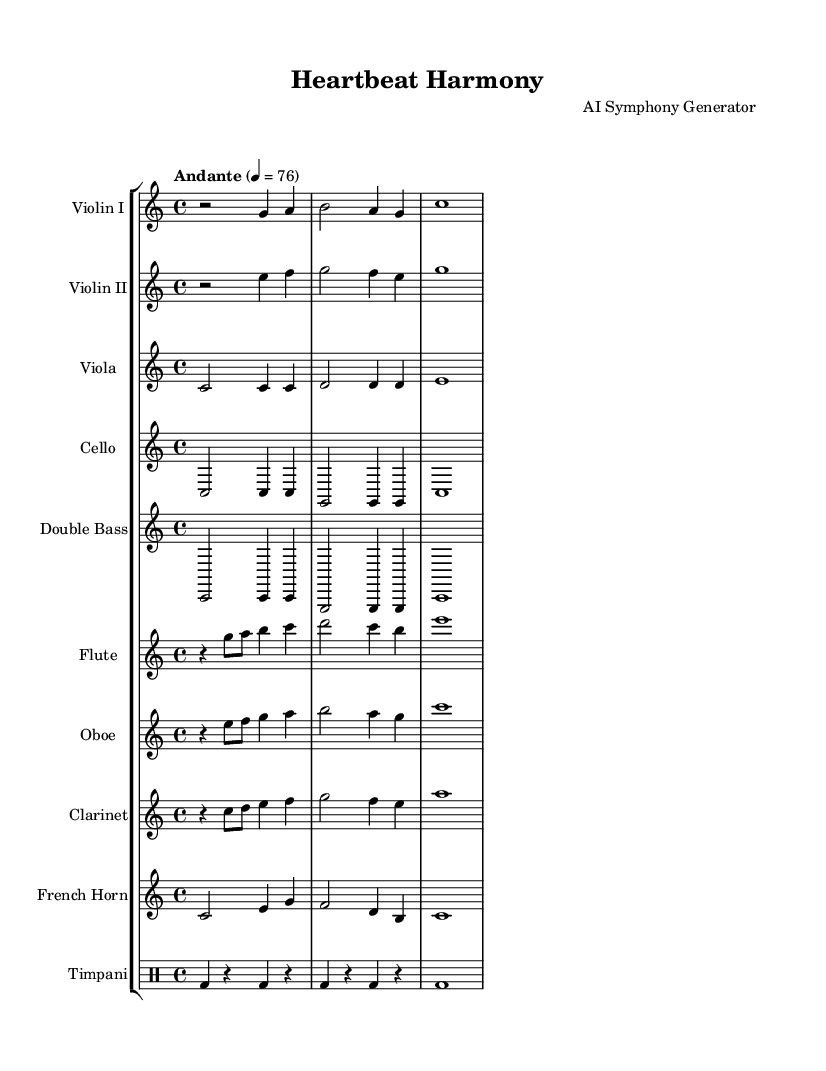What is the key signature of this music? The key signature is indicated by the absence of sharps or flats at the beginning of the staff. In this case, it is C major, which is characterized by this lack of accidentals.
Answer: C major What is the time signature of the piece? The time signature is found at the beginning of the score, displayed as a fraction. Here, it shows a "4/4" indicating there are four beats per measure and the quarter note gets one beat.
Answer: 4/4 What tempo is indicated for this piece? The tempo marking is located at the beginning of the score, showing it as "Andante" with a metronome marking of 76. This describes the speed at which the piece should be played.
Answer: Andante How many instruments are featured in this symphony? To find the number of instruments, we count the different staff lines presented, which includes strings, woodwinds, and percussion. Counting each instrument listed in the StaffGroup reveals there are nine distinct instruments.
Answer: Nine What kind of instrumentation is used for percussion in this music? The percussion part is indicated by the section dedicated to timpani. The notation includes specific drum notes, which categorize it as a percussion instrument within the symphony structure.
Answer: Timpani Which instrument plays the highest range of notes in this symphony? The highest range can be identified by looking at the instrument lines from top to bottom. The flute, which is positioned at the top of the score, generally plays in a higher pitch range compared to the others.
Answer: Flute Which two instruments have similar melodic patterns in this piece? To identify instruments with similar patterns, one must compare their respective staves visually and auditorily. In this piece, the Violin I and Violin II have overlapping note patterns that create a dialogue, or melodic interaction, typical in symphonic writing.
Answer: Violin I and Violin II 